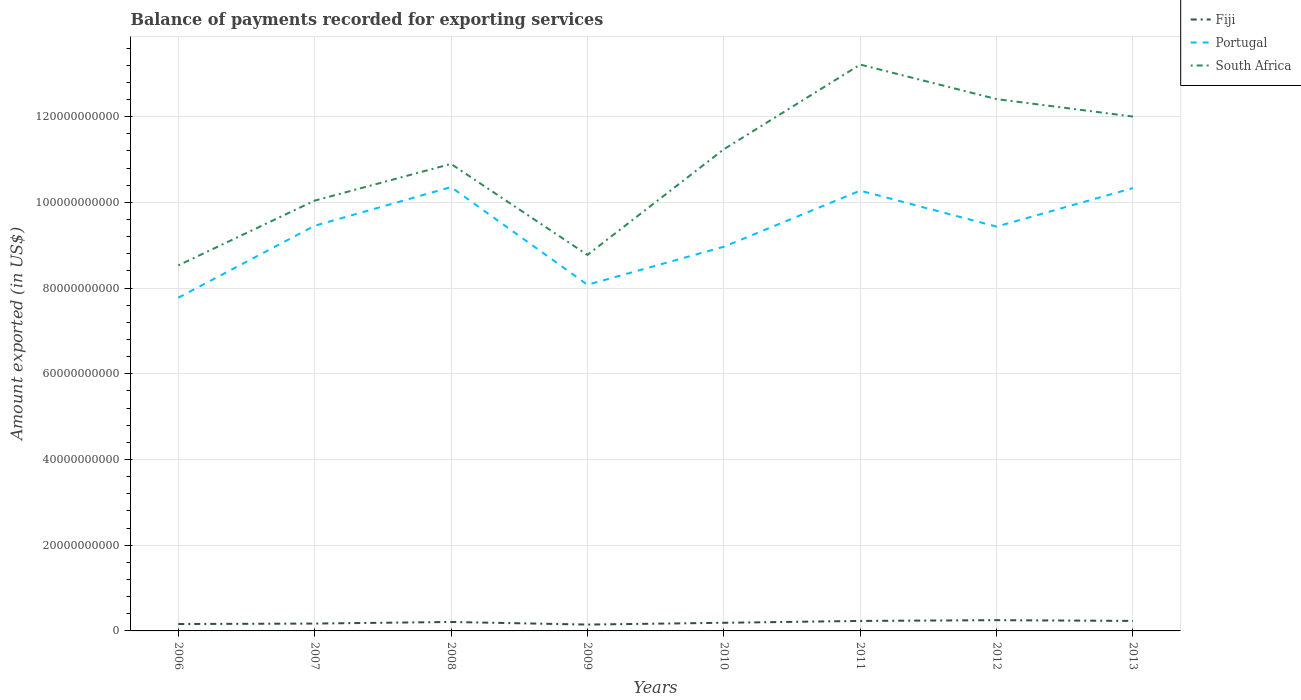How many different coloured lines are there?
Provide a short and direct response. 3. Does the line corresponding to South Africa intersect with the line corresponding to Portugal?
Make the answer very short. No. Across all years, what is the maximum amount exported in Fiji?
Keep it short and to the point. 1.48e+09. In which year was the amount exported in Portugal maximum?
Offer a terse response. 2006. What is the total amount exported in Fiji in the graph?
Give a very brief answer. -3.73e+08. What is the difference between the highest and the second highest amount exported in Portugal?
Offer a terse response. 2.58e+1. What is the difference between the highest and the lowest amount exported in Portugal?
Your response must be concise. 5. Is the amount exported in South Africa strictly greater than the amount exported in Portugal over the years?
Provide a succinct answer. No. Does the graph contain any zero values?
Your answer should be very brief. No. What is the title of the graph?
Give a very brief answer. Balance of payments recorded for exporting services. What is the label or title of the X-axis?
Give a very brief answer. Years. What is the label or title of the Y-axis?
Your response must be concise. Amount exported (in US$). What is the Amount exported (in US$) of Fiji in 2006?
Give a very brief answer. 1.61e+09. What is the Amount exported (in US$) of Portugal in 2006?
Offer a terse response. 7.78e+1. What is the Amount exported (in US$) of South Africa in 2006?
Offer a very short reply. 8.53e+1. What is the Amount exported (in US$) in Fiji in 2007?
Offer a terse response. 1.72e+09. What is the Amount exported (in US$) of Portugal in 2007?
Your response must be concise. 9.45e+1. What is the Amount exported (in US$) of South Africa in 2007?
Your response must be concise. 1.00e+11. What is the Amount exported (in US$) of Fiji in 2008?
Make the answer very short. 2.09e+09. What is the Amount exported (in US$) in Portugal in 2008?
Make the answer very short. 1.04e+11. What is the Amount exported (in US$) in South Africa in 2008?
Your answer should be compact. 1.09e+11. What is the Amount exported (in US$) of Fiji in 2009?
Your response must be concise. 1.48e+09. What is the Amount exported (in US$) of Portugal in 2009?
Give a very brief answer. 8.08e+1. What is the Amount exported (in US$) in South Africa in 2009?
Give a very brief answer. 8.77e+1. What is the Amount exported (in US$) in Fiji in 2010?
Your answer should be compact. 1.90e+09. What is the Amount exported (in US$) in Portugal in 2010?
Your answer should be very brief. 8.96e+1. What is the Amount exported (in US$) in South Africa in 2010?
Make the answer very short. 1.12e+11. What is the Amount exported (in US$) in Fiji in 2011?
Provide a succinct answer. 2.33e+09. What is the Amount exported (in US$) of Portugal in 2011?
Make the answer very short. 1.03e+11. What is the Amount exported (in US$) of South Africa in 2011?
Provide a succinct answer. 1.32e+11. What is the Amount exported (in US$) in Fiji in 2012?
Your answer should be compact. 2.51e+09. What is the Amount exported (in US$) in Portugal in 2012?
Your answer should be very brief. 9.43e+1. What is the Amount exported (in US$) in South Africa in 2012?
Your answer should be very brief. 1.24e+11. What is the Amount exported (in US$) in Fiji in 2013?
Keep it short and to the point. 2.33e+09. What is the Amount exported (in US$) in Portugal in 2013?
Ensure brevity in your answer.  1.03e+11. What is the Amount exported (in US$) in South Africa in 2013?
Offer a terse response. 1.20e+11. Across all years, what is the maximum Amount exported (in US$) of Fiji?
Ensure brevity in your answer.  2.51e+09. Across all years, what is the maximum Amount exported (in US$) of Portugal?
Offer a very short reply. 1.04e+11. Across all years, what is the maximum Amount exported (in US$) in South Africa?
Your answer should be compact. 1.32e+11. Across all years, what is the minimum Amount exported (in US$) of Fiji?
Your answer should be compact. 1.48e+09. Across all years, what is the minimum Amount exported (in US$) of Portugal?
Provide a succinct answer. 7.78e+1. Across all years, what is the minimum Amount exported (in US$) of South Africa?
Your response must be concise. 8.53e+1. What is the total Amount exported (in US$) of Fiji in the graph?
Provide a short and direct response. 1.60e+1. What is the total Amount exported (in US$) of Portugal in the graph?
Provide a succinct answer. 7.47e+11. What is the total Amount exported (in US$) of South Africa in the graph?
Offer a very short reply. 8.71e+11. What is the difference between the Amount exported (in US$) of Fiji in 2006 and that in 2007?
Keep it short and to the point. -1.08e+08. What is the difference between the Amount exported (in US$) of Portugal in 2006 and that in 2007?
Give a very brief answer. -1.68e+1. What is the difference between the Amount exported (in US$) in South Africa in 2006 and that in 2007?
Your answer should be very brief. -1.51e+1. What is the difference between the Amount exported (in US$) of Fiji in 2006 and that in 2008?
Offer a terse response. -4.81e+08. What is the difference between the Amount exported (in US$) of Portugal in 2006 and that in 2008?
Offer a very short reply. -2.58e+1. What is the difference between the Amount exported (in US$) in South Africa in 2006 and that in 2008?
Make the answer very short. -2.37e+1. What is the difference between the Amount exported (in US$) in Fiji in 2006 and that in 2009?
Provide a succinct answer. 1.26e+08. What is the difference between the Amount exported (in US$) in Portugal in 2006 and that in 2009?
Provide a succinct answer. -3.02e+09. What is the difference between the Amount exported (in US$) of South Africa in 2006 and that in 2009?
Give a very brief answer. -2.45e+09. What is the difference between the Amount exported (in US$) of Fiji in 2006 and that in 2010?
Ensure brevity in your answer.  -2.89e+08. What is the difference between the Amount exported (in US$) of Portugal in 2006 and that in 2010?
Offer a terse response. -1.19e+1. What is the difference between the Amount exported (in US$) in South Africa in 2006 and that in 2010?
Make the answer very short. -2.71e+1. What is the difference between the Amount exported (in US$) in Fiji in 2006 and that in 2011?
Your answer should be compact. -7.21e+08. What is the difference between the Amount exported (in US$) of Portugal in 2006 and that in 2011?
Offer a terse response. -2.50e+1. What is the difference between the Amount exported (in US$) in South Africa in 2006 and that in 2011?
Give a very brief answer. -4.69e+1. What is the difference between the Amount exported (in US$) of Fiji in 2006 and that in 2012?
Give a very brief answer. -9.01e+08. What is the difference between the Amount exported (in US$) in Portugal in 2006 and that in 2012?
Offer a terse response. -1.66e+1. What is the difference between the Amount exported (in US$) of South Africa in 2006 and that in 2012?
Give a very brief answer. -3.88e+1. What is the difference between the Amount exported (in US$) in Fiji in 2006 and that in 2013?
Make the answer very short. -7.24e+08. What is the difference between the Amount exported (in US$) in Portugal in 2006 and that in 2013?
Your answer should be very brief. -2.56e+1. What is the difference between the Amount exported (in US$) in South Africa in 2006 and that in 2013?
Your response must be concise. -3.47e+1. What is the difference between the Amount exported (in US$) of Fiji in 2007 and that in 2008?
Provide a succinct answer. -3.73e+08. What is the difference between the Amount exported (in US$) in Portugal in 2007 and that in 2008?
Make the answer very short. -9.03e+09. What is the difference between the Amount exported (in US$) in South Africa in 2007 and that in 2008?
Provide a short and direct response. -8.56e+09. What is the difference between the Amount exported (in US$) of Fiji in 2007 and that in 2009?
Your response must be concise. 2.34e+08. What is the difference between the Amount exported (in US$) of Portugal in 2007 and that in 2009?
Make the answer very short. 1.38e+1. What is the difference between the Amount exported (in US$) in South Africa in 2007 and that in 2009?
Offer a terse response. 1.27e+1. What is the difference between the Amount exported (in US$) of Fiji in 2007 and that in 2010?
Offer a very short reply. -1.82e+08. What is the difference between the Amount exported (in US$) of Portugal in 2007 and that in 2010?
Provide a succinct answer. 4.90e+09. What is the difference between the Amount exported (in US$) of South Africa in 2007 and that in 2010?
Ensure brevity in your answer.  -1.20e+1. What is the difference between the Amount exported (in US$) in Fiji in 2007 and that in 2011?
Keep it short and to the point. -6.14e+08. What is the difference between the Amount exported (in US$) of Portugal in 2007 and that in 2011?
Provide a short and direct response. -8.20e+09. What is the difference between the Amount exported (in US$) in South Africa in 2007 and that in 2011?
Your answer should be compact. -3.17e+1. What is the difference between the Amount exported (in US$) in Fiji in 2007 and that in 2012?
Make the answer very short. -7.94e+08. What is the difference between the Amount exported (in US$) in Portugal in 2007 and that in 2012?
Your answer should be very brief. 2.00e+08. What is the difference between the Amount exported (in US$) of South Africa in 2007 and that in 2012?
Your response must be concise. -2.37e+1. What is the difference between the Amount exported (in US$) in Fiji in 2007 and that in 2013?
Make the answer very short. -6.17e+08. What is the difference between the Amount exported (in US$) in Portugal in 2007 and that in 2013?
Your answer should be compact. -8.79e+09. What is the difference between the Amount exported (in US$) in South Africa in 2007 and that in 2013?
Make the answer very short. -1.96e+1. What is the difference between the Amount exported (in US$) in Fiji in 2008 and that in 2009?
Your answer should be very brief. 6.07e+08. What is the difference between the Amount exported (in US$) of Portugal in 2008 and that in 2009?
Offer a terse response. 2.28e+1. What is the difference between the Amount exported (in US$) in South Africa in 2008 and that in 2009?
Offer a terse response. 2.12e+1. What is the difference between the Amount exported (in US$) of Fiji in 2008 and that in 2010?
Ensure brevity in your answer.  1.92e+08. What is the difference between the Amount exported (in US$) of Portugal in 2008 and that in 2010?
Keep it short and to the point. 1.39e+1. What is the difference between the Amount exported (in US$) of South Africa in 2008 and that in 2010?
Keep it short and to the point. -3.41e+09. What is the difference between the Amount exported (in US$) in Fiji in 2008 and that in 2011?
Offer a terse response. -2.40e+08. What is the difference between the Amount exported (in US$) in Portugal in 2008 and that in 2011?
Offer a very short reply. 8.28e+08. What is the difference between the Amount exported (in US$) of South Africa in 2008 and that in 2011?
Offer a terse response. -2.32e+1. What is the difference between the Amount exported (in US$) in Fiji in 2008 and that in 2012?
Provide a short and direct response. -4.21e+08. What is the difference between the Amount exported (in US$) in Portugal in 2008 and that in 2012?
Keep it short and to the point. 9.23e+09. What is the difference between the Amount exported (in US$) of South Africa in 2008 and that in 2012?
Ensure brevity in your answer.  -1.51e+1. What is the difference between the Amount exported (in US$) of Fiji in 2008 and that in 2013?
Give a very brief answer. -2.43e+08. What is the difference between the Amount exported (in US$) of Portugal in 2008 and that in 2013?
Ensure brevity in your answer.  2.33e+08. What is the difference between the Amount exported (in US$) of South Africa in 2008 and that in 2013?
Make the answer very short. -1.10e+1. What is the difference between the Amount exported (in US$) in Fiji in 2009 and that in 2010?
Provide a succinct answer. -4.15e+08. What is the difference between the Amount exported (in US$) in Portugal in 2009 and that in 2010?
Ensure brevity in your answer.  -8.87e+09. What is the difference between the Amount exported (in US$) in South Africa in 2009 and that in 2010?
Offer a terse response. -2.46e+1. What is the difference between the Amount exported (in US$) of Fiji in 2009 and that in 2011?
Ensure brevity in your answer.  -8.47e+08. What is the difference between the Amount exported (in US$) of Portugal in 2009 and that in 2011?
Your response must be concise. -2.20e+1. What is the difference between the Amount exported (in US$) in South Africa in 2009 and that in 2011?
Provide a succinct answer. -4.44e+1. What is the difference between the Amount exported (in US$) of Fiji in 2009 and that in 2012?
Offer a terse response. -1.03e+09. What is the difference between the Amount exported (in US$) of Portugal in 2009 and that in 2012?
Ensure brevity in your answer.  -1.36e+1. What is the difference between the Amount exported (in US$) of South Africa in 2009 and that in 2012?
Keep it short and to the point. -3.64e+1. What is the difference between the Amount exported (in US$) of Fiji in 2009 and that in 2013?
Offer a very short reply. -8.50e+08. What is the difference between the Amount exported (in US$) of Portugal in 2009 and that in 2013?
Provide a short and direct response. -2.26e+1. What is the difference between the Amount exported (in US$) in South Africa in 2009 and that in 2013?
Give a very brief answer. -3.23e+1. What is the difference between the Amount exported (in US$) of Fiji in 2010 and that in 2011?
Provide a short and direct response. -4.32e+08. What is the difference between the Amount exported (in US$) of Portugal in 2010 and that in 2011?
Offer a very short reply. -1.31e+1. What is the difference between the Amount exported (in US$) of South Africa in 2010 and that in 2011?
Your answer should be very brief. -1.98e+1. What is the difference between the Amount exported (in US$) of Fiji in 2010 and that in 2012?
Your answer should be very brief. -6.12e+08. What is the difference between the Amount exported (in US$) of Portugal in 2010 and that in 2012?
Give a very brief answer. -4.70e+09. What is the difference between the Amount exported (in US$) of South Africa in 2010 and that in 2012?
Offer a very short reply. -1.17e+1. What is the difference between the Amount exported (in US$) in Fiji in 2010 and that in 2013?
Ensure brevity in your answer.  -4.35e+08. What is the difference between the Amount exported (in US$) of Portugal in 2010 and that in 2013?
Ensure brevity in your answer.  -1.37e+1. What is the difference between the Amount exported (in US$) of South Africa in 2010 and that in 2013?
Make the answer very short. -7.64e+09. What is the difference between the Amount exported (in US$) in Fiji in 2011 and that in 2012?
Your response must be concise. -1.80e+08. What is the difference between the Amount exported (in US$) of Portugal in 2011 and that in 2012?
Offer a terse response. 8.40e+09. What is the difference between the Amount exported (in US$) in South Africa in 2011 and that in 2012?
Make the answer very short. 8.05e+09. What is the difference between the Amount exported (in US$) in Fiji in 2011 and that in 2013?
Offer a terse response. -3.06e+06. What is the difference between the Amount exported (in US$) of Portugal in 2011 and that in 2013?
Ensure brevity in your answer.  -5.95e+08. What is the difference between the Amount exported (in US$) in South Africa in 2011 and that in 2013?
Provide a short and direct response. 1.21e+1. What is the difference between the Amount exported (in US$) of Fiji in 2012 and that in 2013?
Your answer should be very brief. 1.77e+08. What is the difference between the Amount exported (in US$) in Portugal in 2012 and that in 2013?
Give a very brief answer. -8.99e+09. What is the difference between the Amount exported (in US$) of South Africa in 2012 and that in 2013?
Your answer should be very brief. 4.08e+09. What is the difference between the Amount exported (in US$) in Fiji in 2006 and the Amount exported (in US$) in Portugal in 2007?
Offer a terse response. -9.29e+1. What is the difference between the Amount exported (in US$) of Fiji in 2006 and the Amount exported (in US$) of South Africa in 2007?
Offer a very short reply. -9.88e+1. What is the difference between the Amount exported (in US$) in Portugal in 2006 and the Amount exported (in US$) in South Africa in 2007?
Ensure brevity in your answer.  -2.27e+1. What is the difference between the Amount exported (in US$) of Fiji in 2006 and the Amount exported (in US$) of Portugal in 2008?
Your answer should be compact. -1.02e+11. What is the difference between the Amount exported (in US$) in Fiji in 2006 and the Amount exported (in US$) in South Africa in 2008?
Ensure brevity in your answer.  -1.07e+11. What is the difference between the Amount exported (in US$) of Portugal in 2006 and the Amount exported (in US$) of South Africa in 2008?
Offer a very short reply. -3.12e+1. What is the difference between the Amount exported (in US$) in Fiji in 2006 and the Amount exported (in US$) in Portugal in 2009?
Provide a succinct answer. -7.92e+1. What is the difference between the Amount exported (in US$) in Fiji in 2006 and the Amount exported (in US$) in South Africa in 2009?
Provide a short and direct response. -8.61e+1. What is the difference between the Amount exported (in US$) of Portugal in 2006 and the Amount exported (in US$) of South Africa in 2009?
Provide a short and direct response. -9.99e+09. What is the difference between the Amount exported (in US$) of Fiji in 2006 and the Amount exported (in US$) of Portugal in 2010?
Make the answer very short. -8.80e+1. What is the difference between the Amount exported (in US$) of Fiji in 2006 and the Amount exported (in US$) of South Africa in 2010?
Provide a succinct answer. -1.11e+11. What is the difference between the Amount exported (in US$) of Portugal in 2006 and the Amount exported (in US$) of South Africa in 2010?
Provide a succinct answer. -3.46e+1. What is the difference between the Amount exported (in US$) of Fiji in 2006 and the Amount exported (in US$) of Portugal in 2011?
Provide a succinct answer. -1.01e+11. What is the difference between the Amount exported (in US$) of Fiji in 2006 and the Amount exported (in US$) of South Africa in 2011?
Your answer should be compact. -1.31e+11. What is the difference between the Amount exported (in US$) in Portugal in 2006 and the Amount exported (in US$) in South Africa in 2011?
Your answer should be very brief. -5.44e+1. What is the difference between the Amount exported (in US$) in Fiji in 2006 and the Amount exported (in US$) in Portugal in 2012?
Your answer should be very brief. -9.27e+1. What is the difference between the Amount exported (in US$) in Fiji in 2006 and the Amount exported (in US$) in South Africa in 2012?
Offer a very short reply. -1.22e+11. What is the difference between the Amount exported (in US$) in Portugal in 2006 and the Amount exported (in US$) in South Africa in 2012?
Provide a succinct answer. -4.64e+1. What is the difference between the Amount exported (in US$) in Fiji in 2006 and the Amount exported (in US$) in Portugal in 2013?
Keep it short and to the point. -1.02e+11. What is the difference between the Amount exported (in US$) of Fiji in 2006 and the Amount exported (in US$) of South Africa in 2013?
Your answer should be very brief. -1.18e+11. What is the difference between the Amount exported (in US$) of Portugal in 2006 and the Amount exported (in US$) of South Africa in 2013?
Ensure brevity in your answer.  -4.23e+1. What is the difference between the Amount exported (in US$) of Fiji in 2007 and the Amount exported (in US$) of Portugal in 2008?
Provide a short and direct response. -1.02e+11. What is the difference between the Amount exported (in US$) of Fiji in 2007 and the Amount exported (in US$) of South Africa in 2008?
Give a very brief answer. -1.07e+11. What is the difference between the Amount exported (in US$) in Portugal in 2007 and the Amount exported (in US$) in South Africa in 2008?
Your answer should be very brief. -1.44e+1. What is the difference between the Amount exported (in US$) of Fiji in 2007 and the Amount exported (in US$) of Portugal in 2009?
Your answer should be compact. -7.91e+1. What is the difference between the Amount exported (in US$) in Fiji in 2007 and the Amount exported (in US$) in South Africa in 2009?
Provide a succinct answer. -8.60e+1. What is the difference between the Amount exported (in US$) in Portugal in 2007 and the Amount exported (in US$) in South Africa in 2009?
Provide a succinct answer. 6.80e+09. What is the difference between the Amount exported (in US$) of Fiji in 2007 and the Amount exported (in US$) of Portugal in 2010?
Your response must be concise. -8.79e+1. What is the difference between the Amount exported (in US$) in Fiji in 2007 and the Amount exported (in US$) in South Africa in 2010?
Your response must be concise. -1.11e+11. What is the difference between the Amount exported (in US$) in Portugal in 2007 and the Amount exported (in US$) in South Africa in 2010?
Offer a terse response. -1.78e+1. What is the difference between the Amount exported (in US$) of Fiji in 2007 and the Amount exported (in US$) of Portugal in 2011?
Offer a terse response. -1.01e+11. What is the difference between the Amount exported (in US$) of Fiji in 2007 and the Amount exported (in US$) of South Africa in 2011?
Your response must be concise. -1.30e+11. What is the difference between the Amount exported (in US$) in Portugal in 2007 and the Amount exported (in US$) in South Africa in 2011?
Provide a succinct answer. -3.76e+1. What is the difference between the Amount exported (in US$) of Fiji in 2007 and the Amount exported (in US$) of Portugal in 2012?
Your answer should be compact. -9.26e+1. What is the difference between the Amount exported (in US$) in Fiji in 2007 and the Amount exported (in US$) in South Africa in 2012?
Your answer should be very brief. -1.22e+11. What is the difference between the Amount exported (in US$) in Portugal in 2007 and the Amount exported (in US$) in South Africa in 2012?
Make the answer very short. -2.96e+1. What is the difference between the Amount exported (in US$) of Fiji in 2007 and the Amount exported (in US$) of Portugal in 2013?
Your answer should be compact. -1.02e+11. What is the difference between the Amount exported (in US$) of Fiji in 2007 and the Amount exported (in US$) of South Africa in 2013?
Your answer should be compact. -1.18e+11. What is the difference between the Amount exported (in US$) in Portugal in 2007 and the Amount exported (in US$) in South Africa in 2013?
Provide a succinct answer. -2.55e+1. What is the difference between the Amount exported (in US$) in Fiji in 2008 and the Amount exported (in US$) in Portugal in 2009?
Keep it short and to the point. -7.87e+1. What is the difference between the Amount exported (in US$) in Fiji in 2008 and the Amount exported (in US$) in South Africa in 2009?
Offer a terse response. -8.57e+1. What is the difference between the Amount exported (in US$) in Portugal in 2008 and the Amount exported (in US$) in South Africa in 2009?
Offer a terse response. 1.58e+1. What is the difference between the Amount exported (in US$) of Fiji in 2008 and the Amount exported (in US$) of Portugal in 2010?
Make the answer very short. -8.76e+1. What is the difference between the Amount exported (in US$) in Fiji in 2008 and the Amount exported (in US$) in South Africa in 2010?
Provide a short and direct response. -1.10e+11. What is the difference between the Amount exported (in US$) in Portugal in 2008 and the Amount exported (in US$) in South Africa in 2010?
Give a very brief answer. -8.81e+09. What is the difference between the Amount exported (in US$) in Fiji in 2008 and the Amount exported (in US$) in Portugal in 2011?
Provide a succinct answer. -1.01e+11. What is the difference between the Amount exported (in US$) in Fiji in 2008 and the Amount exported (in US$) in South Africa in 2011?
Make the answer very short. -1.30e+11. What is the difference between the Amount exported (in US$) in Portugal in 2008 and the Amount exported (in US$) in South Africa in 2011?
Keep it short and to the point. -2.86e+1. What is the difference between the Amount exported (in US$) in Fiji in 2008 and the Amount exported (in US$) in Portugal in 2012?
Offer a very short reply. -9.23e+1. What is the difference between the Amount exported (in US$) of Fiji in 2008 and the Amount exported (in US$) of South Africa in 2012?
Your response must be concise. -1.22e+11. What is the difference between the Amount exported (in US$) of Portugal in 2008 and the Amount exported (in US$) of South Africa in 2012?
Give a very brief answer. -2.05e+1. What is the difference between the Amount exported (in US$) of Fiji in 2008 and the Amount exported (in US$) of Portugal in 2013?
Keep it short and to the point. -1.01e+11. What is the difference between the Amount exported (in US$) of Fiji in 2008 and the Amount exported (in US$) of South Africa in 2013?
Keep it short and to the point. -1.18e+11. What is the difference between the Amount exported (in US$) of Portugal in 2008 and the Amount exported (in US$) of South Africa in 2013?
Ensure brevity in your answer.  -1.64e+1. What is the difference between the Amount exported (in US$) of Fiji in 2009 and the Amount exported (in US$) of Portugal in 2010?
Ensure brevity in your answer.  -8.82e+1. What is the difference between the Amount exported (in US$) in Fiji in 2009 and the Amount exported (in US$) in South Africa in 2010?
Keep it short and to the point. -1.11e+11. What is the difference between the Amount exported (in US$) in Portugal in 2009 and the Amount exported (in US$) in South Africa in 2010?
Provide a short and direct response. -3.16e+1. What is the difference between the Amount exported (in US$) in Fiji in 2009 and the Amount exported (in US$) in Portugal in 2011?
Your answer should be compact. -1.01e+11. What is the difference between the Amount exported (in US$) of Fiji in 2009 and the Amount exported (in US$) of South Africa in 2011?
Keep it short and to the point. -1.31e+11. What is the difference between the Amount exported (in US$) in Portugal in 2009 and the Amount exported (in US$) in South Africa in 2011?
Ensure brevity in your answer.  -5.14e+1. What is the difference between the Amount exported (in US$) of Fiji in 2009 and the Amount exported (in US$) of Portugal in 2012?
Provide a short and direct response. -9.29e+1. What is the difference between the Amount exported (in US$) of Fiji in 2009 and the Amount exported (in US$) of South Africa in 2012?
Offer a terse response. -1.23e+11. What is the difference between the Amount exported (in US$) in Portugal in 2009 and the Amount exported (in US$) in South Africa in 2012?
Your answer should be very brief. -4.33e+1. What is the difference between the Amount exported (in US$) of Fiji in 2009 and the Amount exported (in US$) of Portugal in 2013?
Your answer should be compact. -1.02e+11. What is the difference between the Amount exported (in US$) in Fiji in 2009 and the Amount exported (in US$) in South Africa in 2013?
Provide a short and direct response. -1.19e+11. What is the difference between the Amount exported (in US$) in Portugal in 2009 and the Amount exported (in US$) in South Africa in 2013?
Provide a short and direct response. -3.92e+1. What is the difference between the Amount exported (in US$) in Fiji in 2010 and the Amount exported (in US$) in Portugal in 2011?
Offer a terse response. -1.01e+11. What is the difference between the Amount exported (in US$) of Fiji in 2010 and the Amount exported (in US$) of South Africa in 2011?
Provide a succinct answer. -1.30e+11. What is the difference between the Amount exported (in US$) of Portugal in 2010 and the Amount exported (in US$) of South Africa in 2011?
Make the answer very short. -4.25e+1. What is the difference between the Amount exported (in US$) of Fiji in 2010 and the Amount exported (in US$) of Portugal in 2012?
Offer a very short reply. -9.24e+1. What is the difference between the Amount exported (in US$) in Fiji in 2010 and the Amount exported (in US$) in South Africa in 2012?
Offer a very short reply. -1.22e+11. What is the difference between the Amount exported (in US$) in Portugal in 2010 and the Amount exported (in US$) in South Africa in 2012?
Give a very brief answer. -3.45e+1. What is the difference between the Amount exported (in US$) of Fiji in 2010 and the Amount exported (in US$) of Portugal in 2013?
Ensure brevity in your answer.  -1.01e+11. What is the difference between the Amount exported (in US$) of Fiji in 2010 and the Amount exported (in US$) of South Africa in 2013?
Offer a terse response. -1.18e+11. What is the difference between the Amount exported (in US$) in Portugal in 2010 and the Amount exported (in US$) in South Africa in 2013?
Make the answer very short. -3.04e+1. What is the difference between the Amount exported (in US$) of Fiji in 2011 and the Amount exported (in US$) of Portugal in 2012?
Give a very brief answer. -9.20e+1. What is the difference between the Amount exported (in US$) in Fiji in 2011 and the Amount exported (in US$) in South Africa in 2012?
Provide a short and direct response. -1.22e+11. What is the difference between the Amount exported (in US$) in Portugal in 2011 and the Amount exported (in US$) in South Africa in 2012?
Offer a terse response. -2.14e+1. What is the difference between the Amount exported (in US$) of Fiji in 2011 and the Amount exported (in US$) of Portugal in 2013?
Make the answer very short. -1.01e+11. What is the difference between the Amount exported (in US$) in Fiji in 2011 and the Amount exported (in US$) in South Africa in 2013?
Your answer should be compact. -1.18e+11. What is the difference between the Amount exported (in US$) in Portugal in 2011 and the Amount exported (in US$) in South Africa in 2013?
Keep it short and to the point. -1.73e+1. What is the difference between the Amount exported (in US$) in Fiji in 2012 and the Amount exported (in US$) in Portugal in 2013?
Give a very brief answer. -1.01e+11. What is the difference between the Amount exported (in US$) in Fiji in 2012 and the Amount exported (in US$) in South Africa in 2013?
Provide a short and direct response. -1.18e+11. What is the difference between the Amount exported (in US$) in Portugal in 2012 and the Amount exported (in US$) in South Africa in 2013?
Offer a terse response. -2.57e+1. What is the average Amount exported (in US$) in Fiji per year?
Offer a terse response. 2.00e+09. What is the average Amount exported (in US$) of Portugal per year?
Provide a short and direct response. 9.33e+1. What is the average Amount exported (in US$) in South Africa per year?
Give a very brief answer. 1.09e+11. In the year 2006, what is the difference between the Amount exported (in US$) in Fiji and Amount exported (in US$) in Portugal?
Provide a short and direct response. -7.61e+1. In the year 2006, what is the difference between the Amount exported (in US$) of Fiji and Amount exported (in US$) of South Africa?
Ensure brevity in your answer.  -8.37e+1. In the year 2006, what is the difference between the Amount exported (in US$) of Portugal and Amount exported (in US$) of South Africa?
Provide a succinct answer. -7.54e+09. In the year 2007, what is the difference between the Amount exported (in US$) in Fiji and Amount exported (in US$) in Portugal?
Your response must be concise. -9.28e+1. In the year 2007, what is the difference between the Amount exported (in US$) in Fiji and Amount exported (in US$) in South Africa?
Keep it short and to the point. -9.87e+1. In the year 2007, what is the difference between the Amount exported (in US$) of Portugal and Amount exported (in US$) of South Africa?
Provide a succinct answer. -5.87e+09. In the year 2008, what is the difference between the Amount exported (in US$) in Fiji and Amount exported (in US$) in Portugal?
Your answer should be compact. -1.01e+11. In the year 2008, what is the difference between the Amount exported (in US$) in Fiji and Amount exported (in US$) in South Africa?
Ensure brevity in your answer.  -1.07e+11. In the year 2008, what is the difference between the Amount exported (in US$) of Portugal and Amount exported (in US$) of South Africa?
Offer a terse response. -5.40e+09. In the year 2009, what is the difference between the Amount exported (in US$) in Fiji and Amount exported (in US$) in Portugal?
Offer a terse response. -7.93e+1. In the year 2009, what is the difference between the Amount exported (in US$) of Fiji and Amount exported (in US$) of South Africa?
Give a very brief answer. -8.63e+1. In the year 2009, what is the difference between the Amount exported (in US$) in Portugal and Amount exported (in US$) in South Africa?
Provide a succinct answer. -6.97e+09. In the year 2010, what is the difference between the Amount exported (in US$) in Fiji and Amount exported (in US$) in Portugal?
Make the answer very short. -8.77e+1. In the year 2010, what is the difference between the Amount exported (in US$) of Fiji and Amount exported (in US$) of South Africa?
Offer a very short reply. -1.10e+11. In the year 2010, what is the difference between the Amount exported (in US$) of Portugal and Amount exported (in US$) of South Africa?
Give a very brief answer. -2.27e+1. In the year 2011, what is the difference between the Amount exported (in US$) in Fiji and Amount exported (in US$) in Portugal?
Offer a terse response. -1.00e+11. In the year 2011, what is the difference between the Amount exported (in US$) in Fiji and Amount exported (in US$) in South Africa?
Make the answer very short. -1.30e+11. In the year 2011, what is the difference between the Amount exported (in US$) in Portugal and Amount exported (in US$) in South Africa?
Ensure brevity in your answer.  -2.94e+1. In the year 2012, what is the difference between the Amount exported (in US$) in Fiji and Amount exported (in US$) in Portugal?
Ensure brevity in your answer.  -9.18e+1. In the year 2012, what is the difference between the Amount exported (in US$) in Fiji and Amount exported (in US$) in South Africa?
Make the answer very short. -1.22e+11. In the year 2012, what is the difference between the Amount exported (in US$) of Portugal and Amount exported (in US$) of South Africa?
Make the answer very short. -2.98e+1. In the year 2013, what is the difference between the Amount exported (in US$) in Fiji and Amount exported (in US$) in Portugal?
Your answer should be very brief. -1.01e+11. In the year 2013, what is the difference between the Amount exported (in US$) in Fiji and Amount exported (in US$) in South Africa?
Make the answer very short. -1.18e+11. In the year 2013, what is the difference between the Amount exported (in US$) of Portugal and Amount exported (in US$) of South Africa?
Provide a succinct answer. -1.67e+1. What is the ratio of the Amount exported (in US$) of Fiji in 2006 to that in 2007?
Your answer should be very brief. 0.94. What is the ratio of the Amount exported (in US$) in Portugal in 2006 to that in 2007?
Offer a terse response. 0.82. What is the ratio of the Amount exported (in US$) of South Africa in 2006 to that in 2007?
Ensure brevity in your answer.  0.85. What is the ratio of the Amount exported (in US$) of Fiji in 2006 to that in 2008?
Make the answer very short. 0.77. What is the ratio of the Amount exported (in US$) in Portugal in 2006 to that in 2008?
Offer a terse response. 0.75. What is the ratio of the Amount exported (in US$) of South Africa in 2006 to that in 2008?
Provide a short and direct response. 0.78. What is the ratio of the Amount exported (in US$) of Fiji in 2006 to that in 2009?
Provide a short and direct response. 1.09. What is the ratio of the Amount exported (in US$) of Portugal in 2006 to that in 2009?
Provide a short and direct response. 0.96. What is the ratio of the Amount exported (in US$) in South Africa in 2006 to that in 2009?
Give a very brief answer. 0.97. What is the ratio of the Amount exported (in US$) in Fiji in 2006 to that in 2010?
Provide a short and direct response. 0.85. What is the ratio of the Amount exported (in US$) of Portugal in 2006 to that in 2010?
Offer a terse response. 0.87. What is the ratio of the Amount exported (in US$) in South Africa in 2006 to that in 2010?
Offer a terse response. 0.76. What is the ratio of the Amount exported (in US$) of Fiji in 2006 to that in 2011?
Keep it short and to the point. 0.69. What is the ratio of the Amount exported (in US$) of Portugal in 2006 to that in 2011?
Your answer should be very brief. 0.76. What is the ratio of the Amount exported (in US$) in South Africa in 2006 to that in 2011?
Your answer should be very brief. 0.65. What is the ratio of the Amount exported (in US$) in Fiji in 2006 to that in 2012?
Offer a very short reply. 0.64. What is the ratio of the Amount exported (in US$) of Portugal in 2006 to that in 2012?
Ensure brevity in your answer.  0.82. What is the ratio of the Amount exported (in US$) in South Africa in 2006 to that in 2012?
Keep it short and to the point. 0.69. What is the ratio of the Amount exported (in US$) in Fiji in 2006 to that in 2013?
Make the answer very short. 0.69. What is the ratio of the Amount exported (in US$) of Portugal in 2006 to that in 2013?
Keep it short and to the point. 0.75. What is the ratio of the Amount exported (in US$) of South Africa in 2006 to that in 2013?
Ensure brevity in your answer.  0.71. What is the ratio of the Amount exported (in US$) of Fiji in 2007 to that in 2008?
Offer a terse response. 0.82. What is the ratio of the Amount exported (in US$) of Portugal in 2007 to that in 2008?
Keep it short and to the point. 0.91. What is the ratio of the Amount exported (in US$) of South Africa in 2007 to that in 2008?
Offer a terse response. 0.92. What is the ratio of the Amount exported (in US$) of Fiji in 2007 to that in 2009?
Offer a terse response. 1.16. What is the ratio of the Amount exported (in US$) of Portugal in 2007 to that in 2009?
Your answer should be very brief. 1.17. What is the ratio of the Amount exported (in US$) in South Africa in 2007 to that in 2009?
Offer a very short reply. 1.14. What is the ratio of the Amount exported (in US$) in Fiji in 2007 to that in 2010?
Keep it short and to the point. 0.9. What is the ratio of the Amount exported (in US$) in Portugal in 2007 to that in 2010?
Offer a terse response. 1.05. What is the ratio of the Amount exported (in US$) in South Africa in 2007 to that in 2010?
Give a very brief answer. 0.89. What is the ratio of the Amount exported (in US$) of Fiji in 2007 to that in 2011?
Your response must be concise. 0.74. What is the ratio of the Amount exported (in US$) of Portugal in 2007 to that in 2011?
Provide a succinct answer. 0.92. What is the ratio of the Amount exported (in US$) of South Africa in 2007 to that in 2011?
Make the answer very short. 0.76. What is the ratio of the Amount exported (in US$) in Fiji in 2007 to that in 2012?
Offer a terse response. 0.68. What is the ratio of the Amount exported (in US$) in Portugal in 2007 to that in 2012?
Your answer should be very brief. 1. What is the ratio of the Amount exported (in US$) in South Africa in 2007 to that in 2012?
Offer a terse response. 0.81. What is the ratio of the Amount exported (in US$) of Fiji in 2007 to that in 2013?
Ensure brevity in your answer.  0.74. What is the ratio of the Amount exported (in US$) of Portugal in 2007 to that in 2013?
Ensure brevity in your answer.  0.91. What is the ratio of the Amount exported (in US$) in South Africa in 2007 to that in 2013?
Offer a terse response. 0.84. What is the ratio of the Amount exported (in US$) of Fiji in 2008 to that in 2009?
Offer a terse response. 1.41. What is the ratio of the Amount exported (in US$) in Portugal in 2008 to that in 2009?
Ensure brevity in your answer.  1.28. What is the ratio of the Amount exported (in US$) of South Africa in 2008 to that in 2009?
Keep it short and to the point. 1.24. What is the ratio of the Amount exported (in US$) in Fiji in 2008 to that in 2010?
Offer a terse response. 1.1. What is the ratio of the Amount exported (in US$) in Portugal in 2008 to that in 2010?
Your response must be concise. 1.16. What is the ratio of the Amount exported (in US$) in South Africa in 2008 to that in 2010?
Keep it short and to the point. 0.97. What is the ratio of the Amount exported (in US$) in Fiji in 2008 to that in 2011?
Give a very brief answer. 0.9. What is the ratio of the Amount exported (in US$) in South Africa in 2008 to that in 2011?
Make the answer very short. 0.82. What is the ratio of the Amount exported (in US$) of Fiji in 2008 to that in 2012?
Your answer should be very brief. 0.83. What is the ratio of the Amount exported (in US$) of Portugal in 2008 to that in 2012?
Give a very brief answer. 1.1. What is the ratio of the Amount exported (in US$) of South Africa in 2008 to that in 2012?
Provide a short and direct response. 0.88. What is the ratio of the Amount exported (in US$) of Fiji in 2008 to that in 2013?
Offer a terse response. 0.9. What is the ratio of the Amount exported (in US$) in South Africa in 2008 to that in 2013?
Offer a terse response. 0.91. What is the ratio of the Amount exported (in US$) of Fiji in 2009 to that in 2010?
Ensure brevity in your answer.  0.78. What is the ratio of the Amount exported (in US$) in Portugal in 2009 to that in 2010?
Make the answer very short. 0.9. What is the ratio of the Amount exported (in US$) in South Africa in 2009 to that in 2010?
Offer a terse response. 0.78. What is the ratio of the Amount exported (in US$) in Fiji in 2009 to that in 2011?
Your response must be concise. 0.64. What is the ratio of the Amount exported (in US$) in Portugal in 2009 to that in 2011?
Give a very brief answer. 0.79. What is the ratio of the Amount exported (in US$) of South Africa in 2009 to that in 2011?
Your answer should be very brief. 0.66. What is the ratio of the Amount exported (in US$) in Fiji in 2009 to that in 2012?
Keep it short and to the point. 0.59. What is the ratio of the Amount exported (in US$) in Portugal in 2009 to that in 2012?
Make the answer very short. 0.86. What is the ratio of the Amount exported (in US$) in South Africa in 2009 to that in 2012?
Your answer should be compact. 0.71. What is the ratio of the Amount exported (in US$) of Fiji in 2009 to that in 2013?
Ensure brevity in your answer.  0.64. What is the ratio of the Amount exported (in US$) of Portugal in 2009 to that in 2013?
Offer a terse response. 0.78. What is the ratio of the Amount exported (in US$) of South Africa in 2009 to that in 2013?
Provide a short and direct response. 0.73. What is the ratio of the Amount exported (in US$) in Fiji in 2010 to that in 2011?
Give a very brief answer. 0.81. What is the ratio of the Amount exported (in US$) in Portugal in 2010 to that in 2011?
Give a very brief answer. 0.87. What is the ratio of the Amount exported (in US$) of South Africa in 2010 to that in 2011?
Ensure brevity in your answer.  0.85. What is the ratio of the Amount exported (in US$) in Fiji in 2010 to that in 2012?
Provide a short and direct response. 0.76. What is the ratio of the Amount exported (in US$) of Portugal in 2010 to that in 2012?
Offer a very short reply. 0.95. What is the ratio of the Amount exported (in US$) in South Africa in 2010 to that in 2012?
Offer a terse response. 0.91. What is the ratio of the Amount exported (in US$) in Fiji in 2010 to that in 2013?
Offer a very short reply. 0.81. What is the ratio of the Amount exported (in US$) in Portugal in 2010 to that in 2013?
Your answer should be compact. 0.87. What is the ratio of the Amount exported (in US$) of South Africa in 2010 to that in 2013?
Your answer should be very brief. 0.94. What is the ratio of the Amount exported (in US$) of Fiji in 2011 to that in 2012?
Ensure brevity in your answer.  0.93. What is the ratio of the Amount exported (in US$) in Portugal in 2011 to that in 2012?
Your answer should be compact. 1.09. What is the ratio of the Amount exported (in US$) of South Africa in 2011 to that in 2012?
Offer a very short reply. 1.06. What is the ratio of the Amount exported (in US$) of Fiji in 2011 to that in 2013?
Your answer should be very brief. 1. What is the ratio of the Amount exported (in US$) of South Africa in 2011 to that in 2013?
Your response must be concise. 1.1. What is the ratio of the Amount exported (in US$) in Fiji in 2012 to that in 2013?
Your response must be concise. 1.08. What is the ratio of the Amount exported (in US$) of South Africa in 2012 to that in 2013?
Provide a succinct answer. 1.03. What is the difference between the highest and the second highest Amount exported (in US$) of Fiji?
Your answer should be compact. 1.77e+08. What is the difference between the highest and the second highest Amount exported (in US$) of Portugal?
Your response must be concise. 2.33e+08. What is the difference between the highest and the second highest Amount exported (in US$) in South Africa?
Your response must be concise. 8.05e+09. What is the difference between the highest and the lowest Amount exported (in US$) of Fiji?
Your answer should be compact. 1.03e+09. What is the difference between the highest and the lowest Amount exported (in US$) in Portugal?
Provide a short and direct response. 2.58e+1. What is the difference between the highest and the lowest Amount exported (in US$) of South Africa?
Keep it short and to the point. 4.69e+1. 